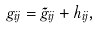<formula> <loc_0><loc_0><loc_500><loc_500>g _ { i j } = \tilde { g } _ { i j } + h _ { i j } ,</formula> 